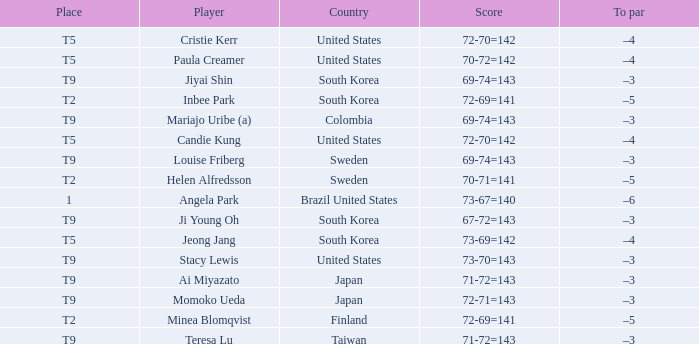Which country placed t9 and had the player jiyai shin? South Korea. 